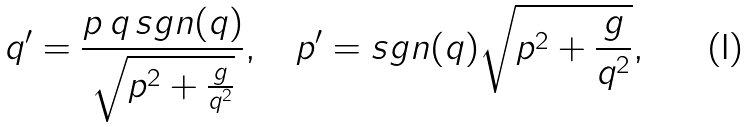<formula> <loc_0><loc_0><loc_500><loc_500>q ^ { \prime } = \frac { p \, q \, s g n ( q ) } { \sqrt { p ^ { 2 } + \frac { g } { q ^ { 2 } } } } , \quad p ^ { \prime } = s g n ( q ) \sqrt { p ^ { 2 } + \frac { g } { q ^ { 2 } } } ,</formula> 